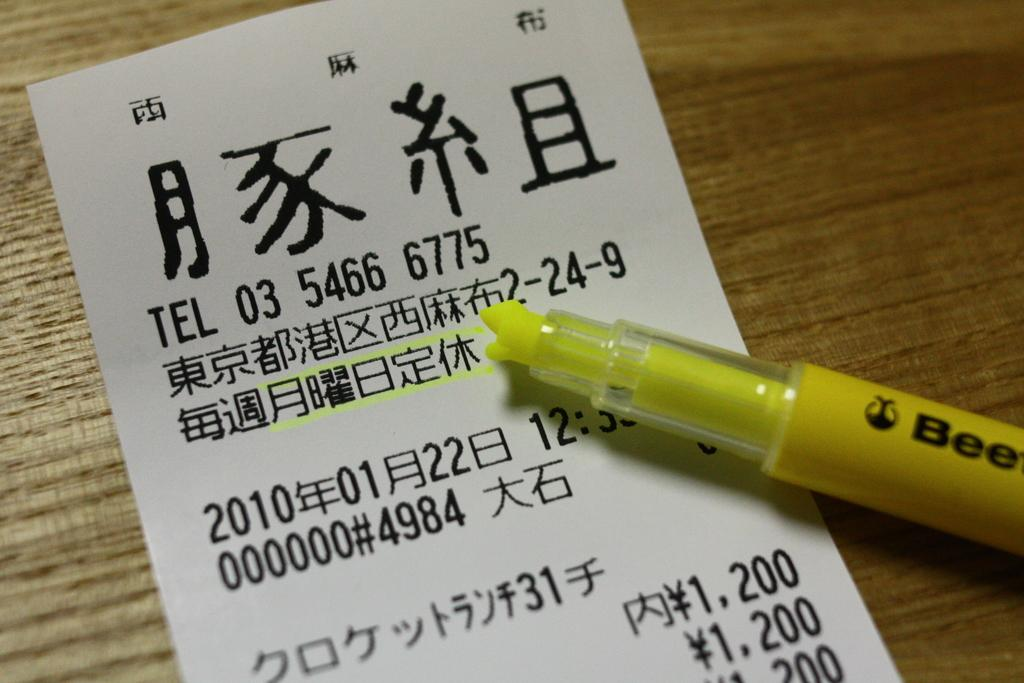What is the primary object in the image? There is a white paper in the image. What can be seen on the paper? Something is written on the paper. What tool is visible in the image? There is a highlighter visible in the image. What type of alley is visible in the background of the image? There is no alley present in the image; it only features a white paper with writing and a highlighter. 